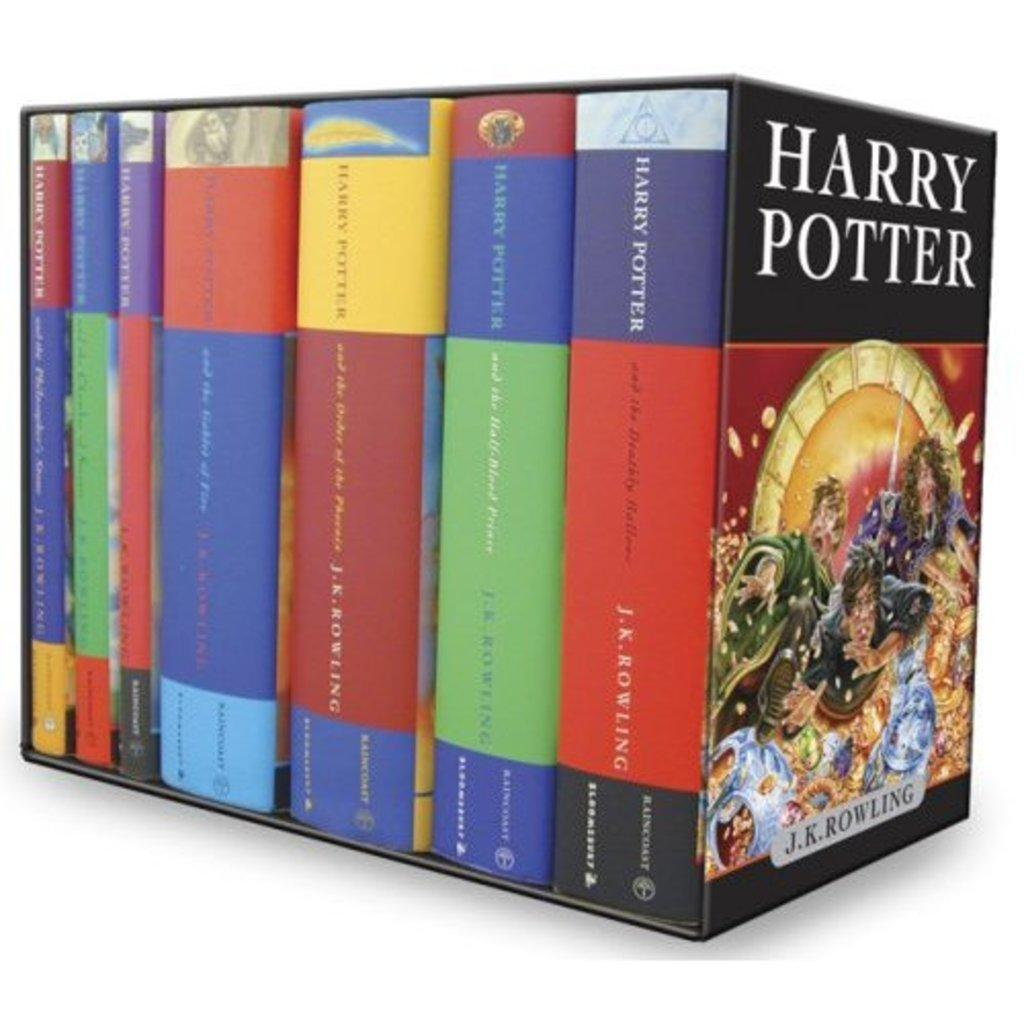<image>
Present a compact description of the photo's key features. A case set of the Harry potter books in various colors. 